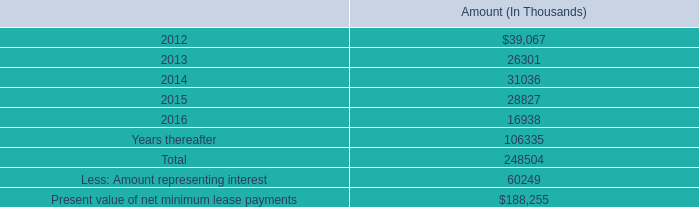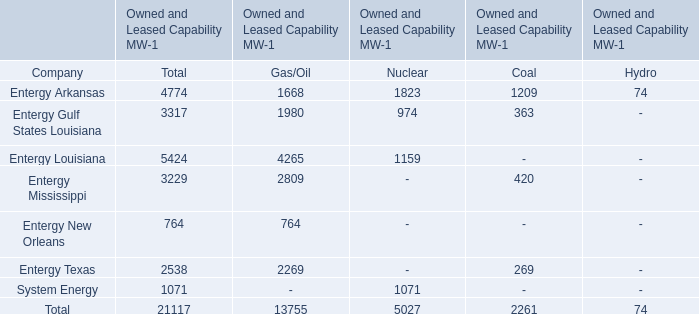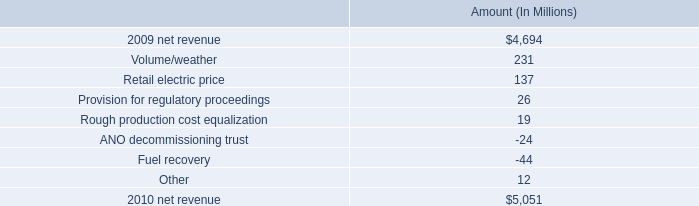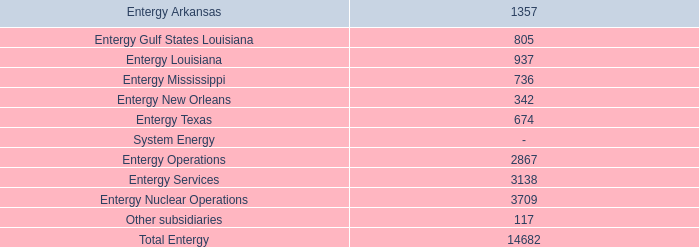What's the total value of all Owned and Leased Capability MW kinds that are in the range of 1000 and 2000 for Entergy Arkansas? 
Computations: ((1668 + 1823) + 1209)
Answer: 4700.0. 